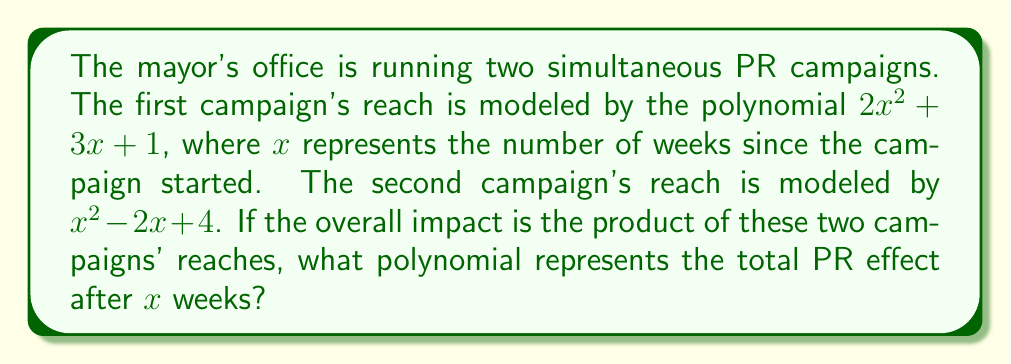Give your solution to this math problem. To find the total PR effect, we need to multiply the two polynomials representing each campaign's reach:

$(2x^2 + 3x + 1)(x^2 - 2x + 4)$

Let's multiply these polynomials using the FOIL method and combining like terms:

1) First, multiply $2x^2$ by each term in the second polynomial:
   $2x^2(x^2) = 2x^4$
   $2x^2(-2x) = -4x^3$
   $2x^2(4) = 8x^2$

2) Next, multiply $3x$ by each term in the second polynomial:
   $3x(x^2) = 3x^3$
   $3x(-2x) = -6x^2$
   $3x(4) = 12x$

3) Finally, multiply 1 by each term in the second polynomial:
   $1(x^2) = x^2$
   $1(-2x) = -2x$
   $1(4) = 4$

4) Now, combine all these terms:
   $2x^4 - 4x^3 + 8x^2 + 3x^3 - 6x^2 + 12x + x^2 - 2x + 4$

5) Simplify by combining like terms:
   $2x^4 + (-4x^3 + 3x^3) + (8x^2 - 6x^2 + x^2) + (12x - 2x) + 4$
   $= 2x^4 - x^3 + 3x^2 + 10x + 4$

This polynomial represents the total PR effect after $x$ weeks, accounting for the overlapping impact of both campaigns.
Answer: $2x^4 - x^3 + 3x^2 + 10x + 4$ 